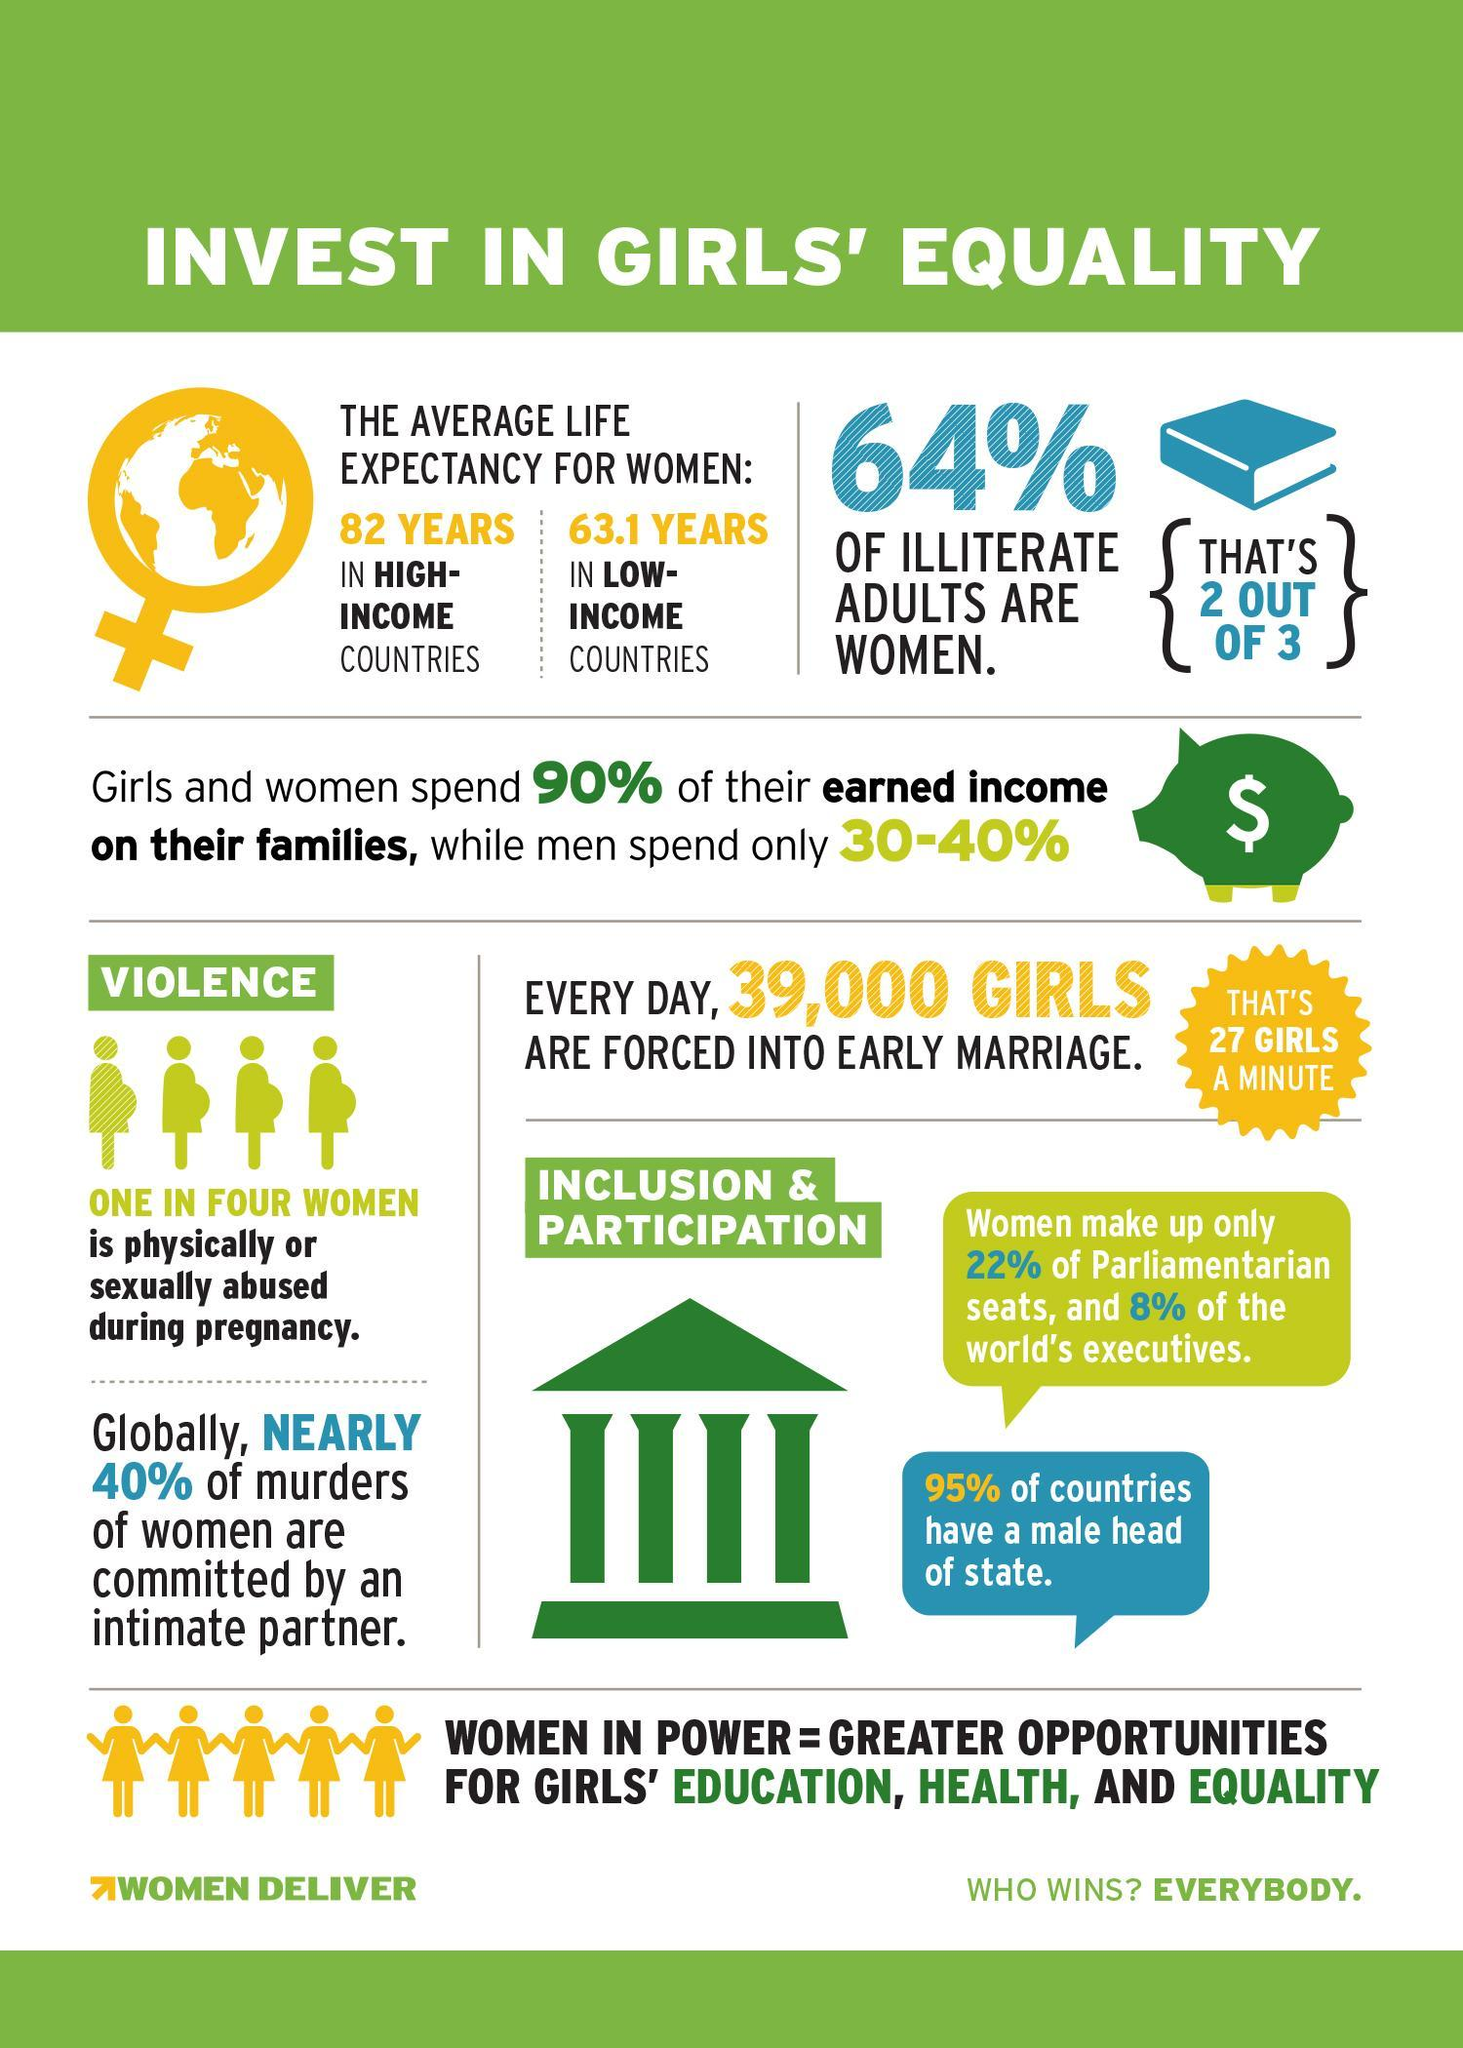What percentage of the world's executives are not women?
Answer the question with a short phrase. 92% What percentage of illiterate adults are not women? 36% 